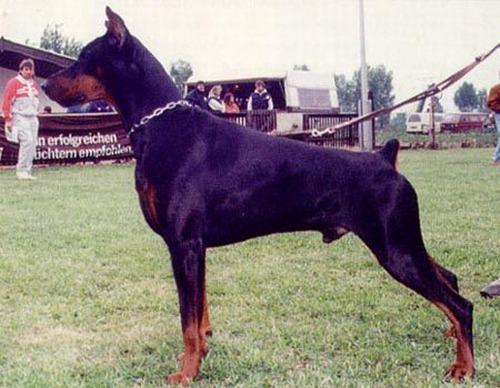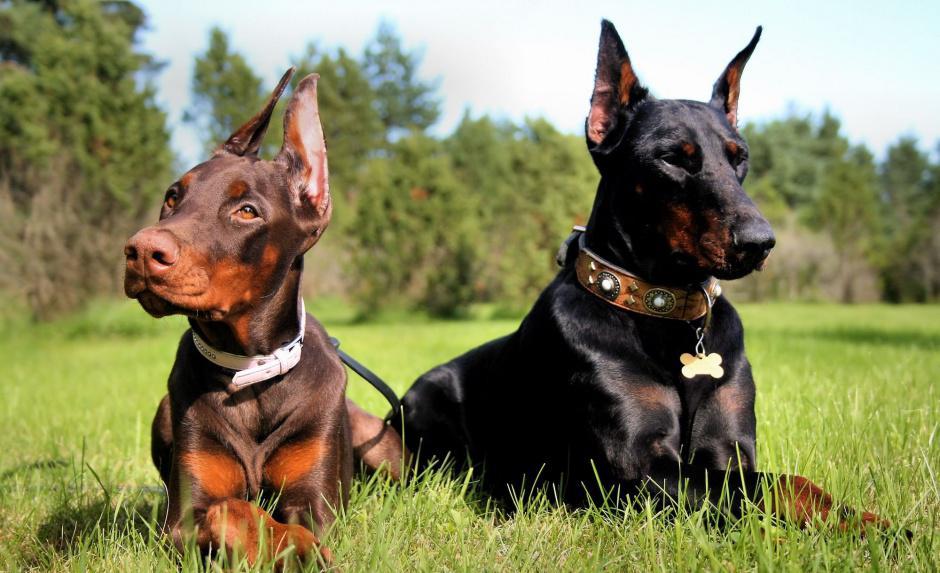The first image is the image on the left, the second image is the image on the right. Considering the images on both sides, is "there are two dogs side by side , at least one dog has dog tags on it's collar" valid? Answer yes or no. Yes. The first image is the image on the left, the second image is the image on the right. Analyze the images presented: Is the assertion "One dog stands alone in the image on the left, and the right image shows a person standing by at least one doberman." valid? Answer yes or no. No. 